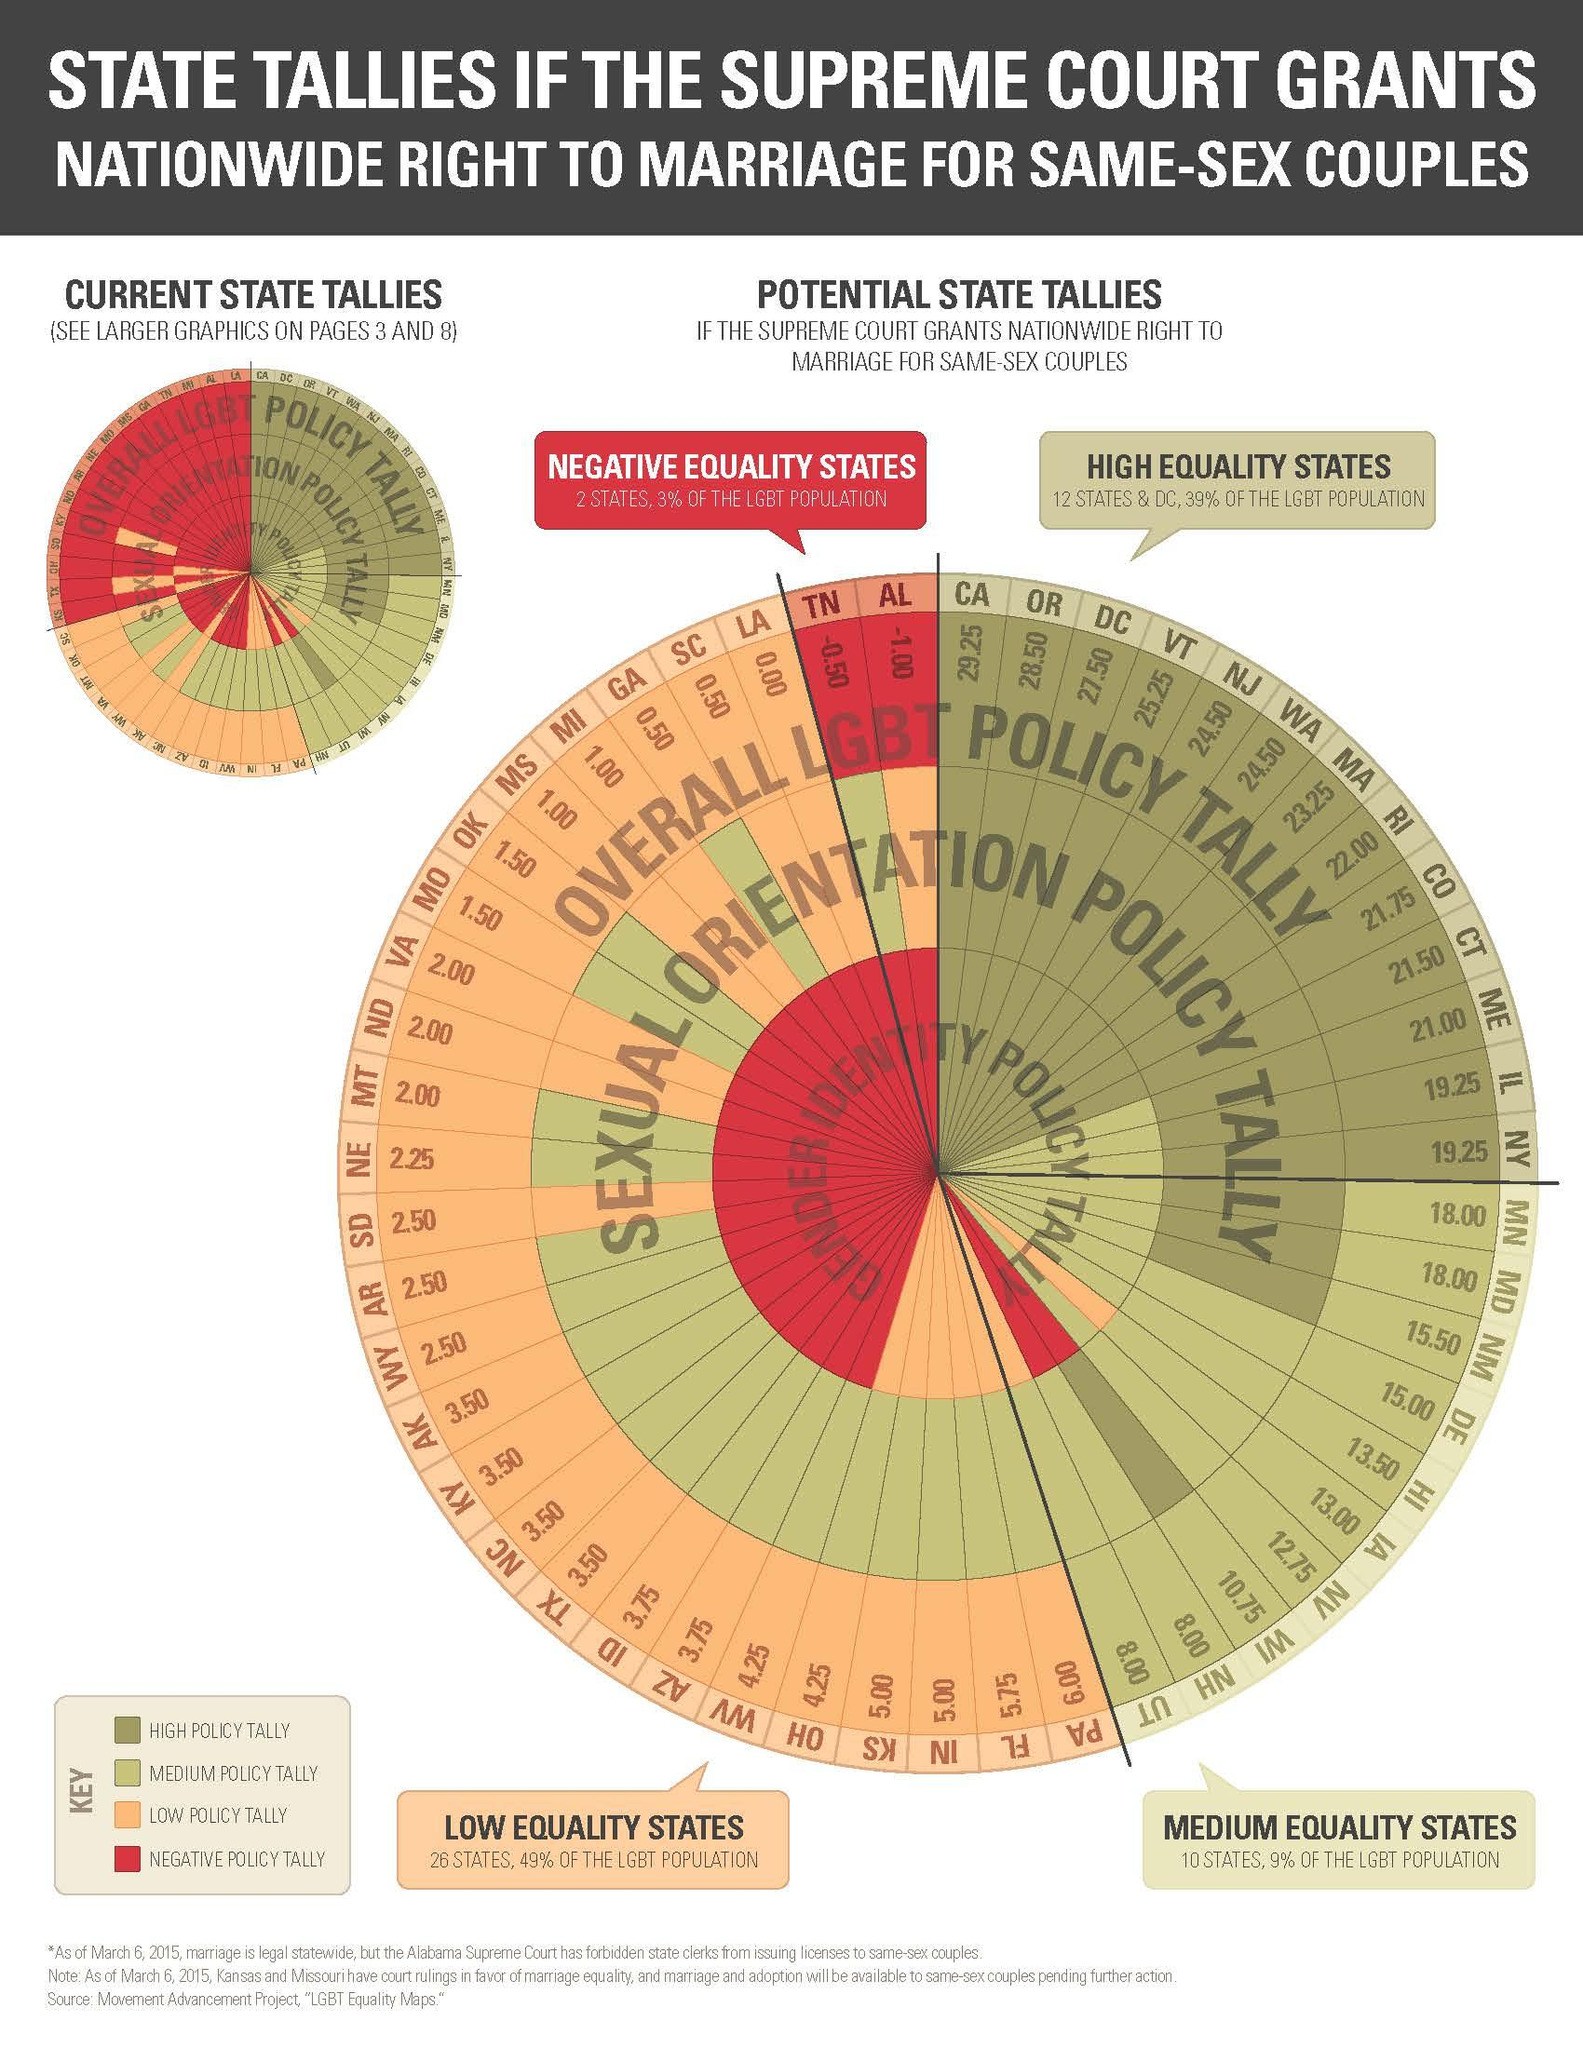Indicate a few pertinent items in this graphic. The key indicates that the red color represents a negative policy tally, There are 22 states that have high or medium levels of equality, according to the given information. The color that is used to represent low policy tally is yellow. The states of Tennessee and Alabama are characterized by negative equality, meaning that the income level of the top 1% is significantly higher than that of the bottom 99%. 